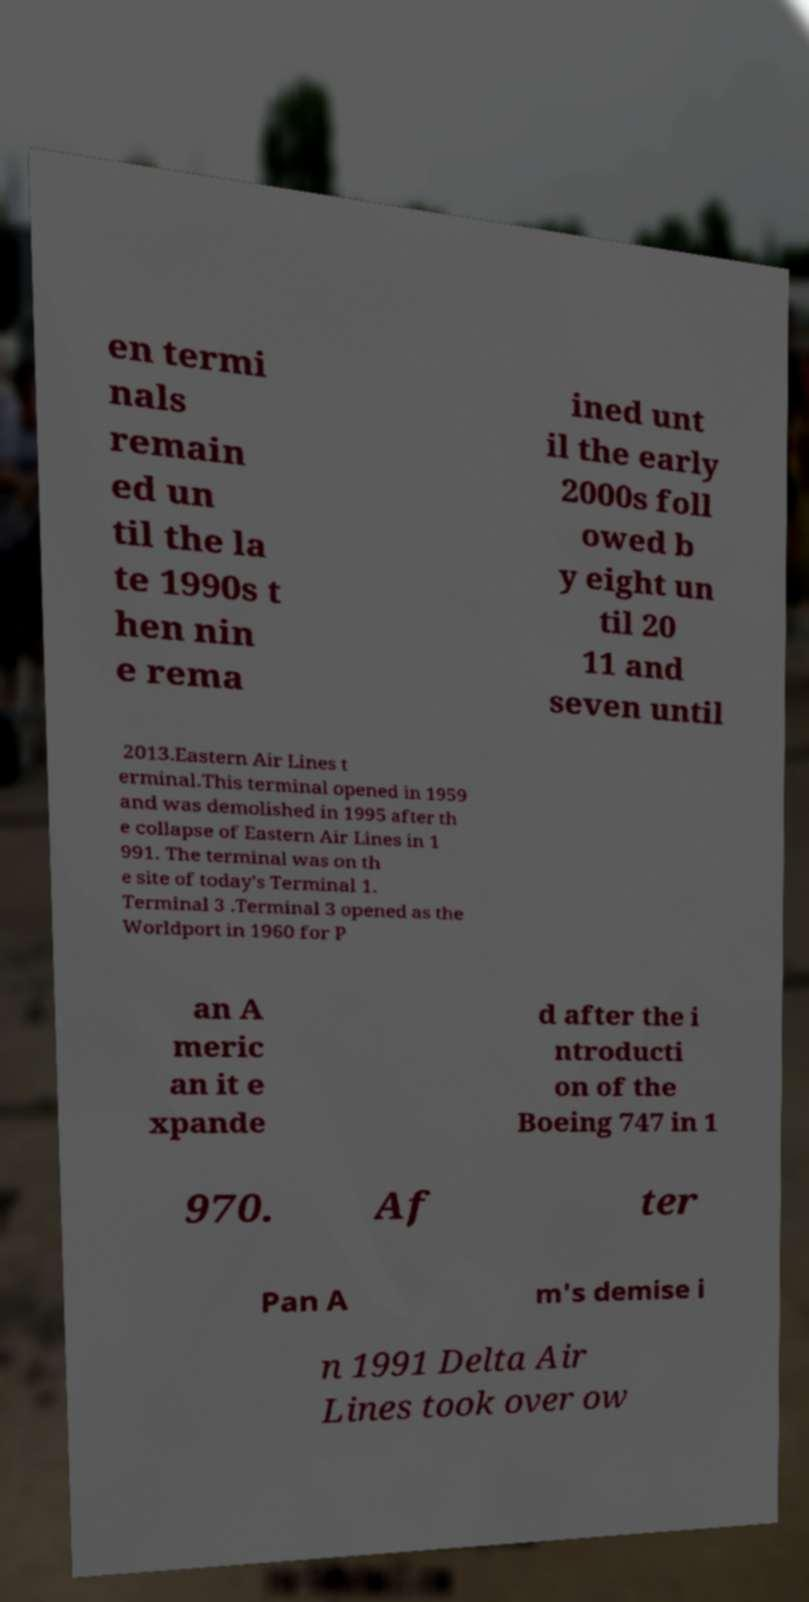There's text embedded in this image that I need extracted. Can you transcribe it verbatim? en termi nals remain ed un til the la te 1990s t hen nin e rema ined unt il the early 2000s foll owed b y eight un til 20 11 and seven until 2013.Eastern Air Lines t erminal.This terminal opened in 1959 and was demolished in 1995 after th e collapse of Eastern Air Lines in 1 991. The terminal was on th e site of today's Terminal 1. Terminal 3 .Terminal 3 opened as the Worldport in 1960 for P an A meric an it e xpande d after the i ntroducti on of the Boeing 747 in 1 970. Af ter Pan A m's demise i n 1991 Delta Air Lines took over ow 